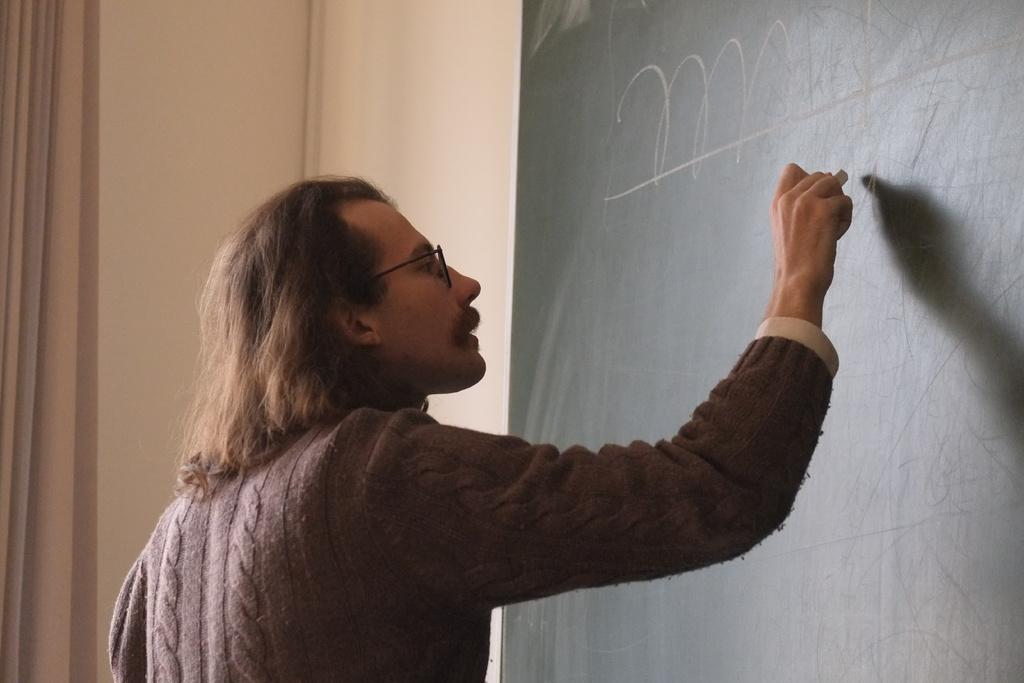What is the main subject of the image? There is a person in the image. What is the person holding in the image? The person is holding a chalk. What is the person doing with the chalk? The person is writing on a board. Where is the board located in the image? The board is attached to a wall. What type of throne is depicted in the image? There is no throne present in the image. Is the person in the image teaching at a school? The image does not provide any information about the location or context of the person's actions, so it cannot be determined if they are at a school. 